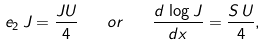<formula> <loc_0><loc_0><loc_500><loc_500>e _ { 2 } \, J = \frac { J U } { 4 } \quad o r \quad \frac { d \, \log J } { d x } = \frac { S \, U } { 4 } ,</formula> 